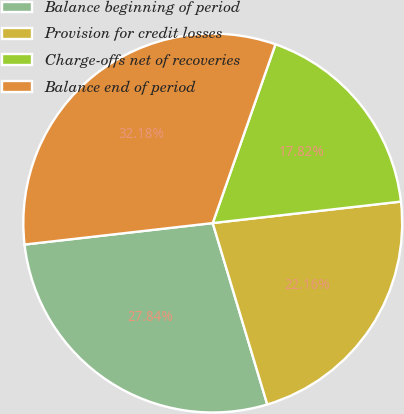Convert chart. <chart><loc_0><loc_0><loc_500><loc_500><pie_chart><fcel>Balance beginning of period<fcel>Provision for credit losses<fcel>Charge-offs net of recoveries<fcel>Balance end of period<nl><fcel>27.84%<fcel>22.16%<fcel>17.82%<fcel>32.18%<nl></chart> 